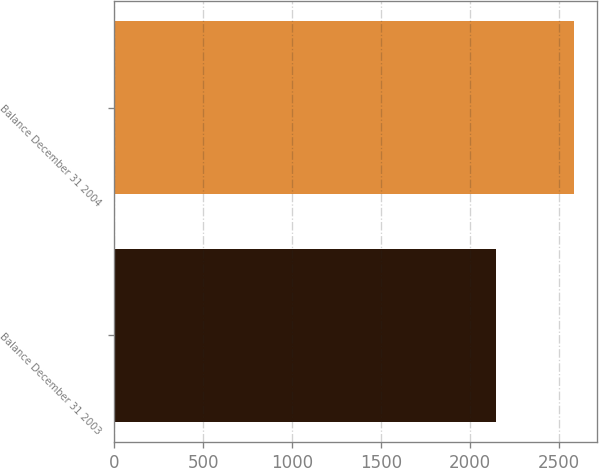<chart> <loc_0><loc_0><loc_500><loc_500><bar_chart><fcel>Balance December 31 2003<fcel>Balance December 31 2004<nl><fcel>2148<fcel>2587<nl></chart> 